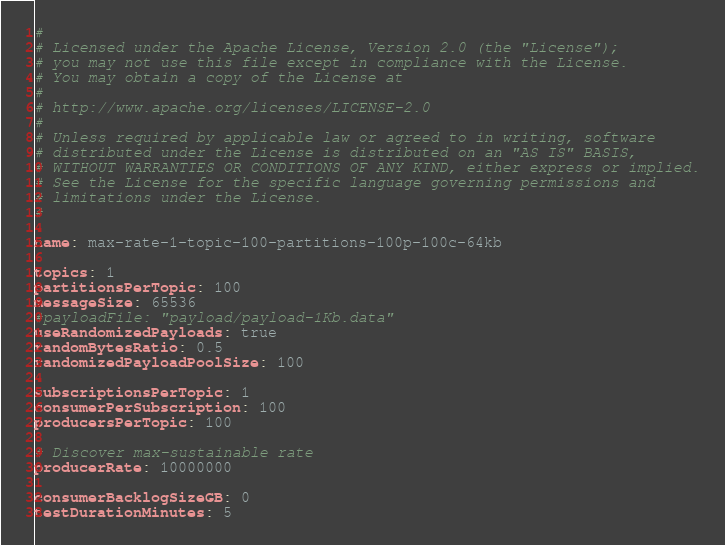<code> <loc_0><loc_0><loc_500><loc_500><_YAML_>#
# Licensed under the Apache License, Version 2.0 (the "License");
# you may not use this file except in compliance with the License.
# You may obtain a copy of the License at
#
# http://www.apache.org/licenses/LICENSE-2.0
#
# Unless required by applicable law or agreed to in writing, software
# distributed under the License is distributed on an "AS IS" BASIS,
# WITHOUT WARRANTIES OR CONDITIONS OF ANY KIND, either express or implied.
# See the License for the specific language governing permissions and
# limitations under the License.
#

name: max-rate-1-topic-100-partitions-100p-100c-64kb

topics: 1
partitionsPerTopic: 100
messageSize: 65536
#payloadFile: "payload/payload-1Kb.data"
useRandomizedPayloads: true
randomBytesRatio: 0.5
randomizedPayloadPoolSize: 100

subscriptionsPerTopic: 1
consumerPerSubscription: 100
producersPerTopic: 100

# Discover max-sustainable rate
producerRate: 10000000

consumerBacklogSizeGB: 0
testDurationMinutes: 5
</code> 